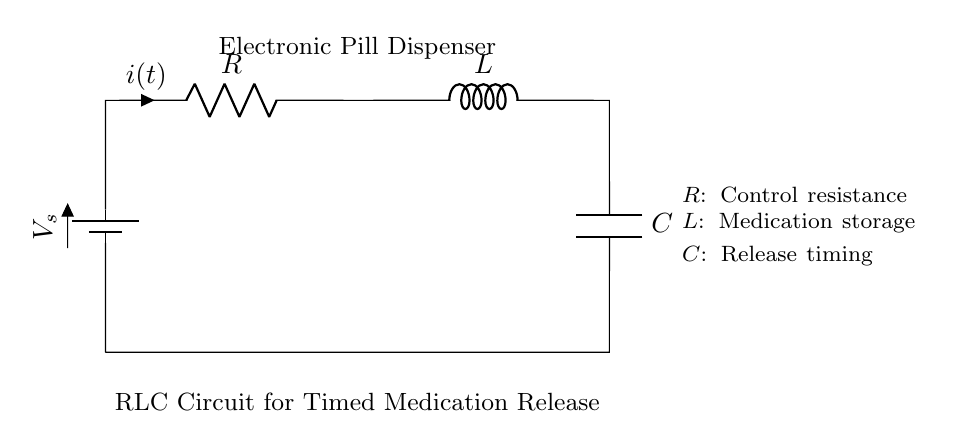What is the control component in the circuit? The control component is the resistor, which is labeled as R. It is used to manage the current flow within the circuit.
Answer: resistor What is the electrical component used for timing in this circuit? The electrical component used for timing is the capacitor, labeled as C. It stores energy and releases it to control the timing of medication release.
Answer: capacitor What do the components R, L, and C represent? R represents control resistance, L represents medication storage, and C represents release timing as described in the circuit diagram.
Answer: control resistance, medication storage, release timing How is the medication stored in the circuit? Medication is stored in the inductor, which is labeled as L. The inductor holds energy in a magnetic field when current passes through it.
Answer: inductor What is the primary purpose of this RLC circuit in an electronic pill dispenser? The primary purpose is to regulate the release of medication over time by controlling current flow, timing, and energy storage.
Answer: regulate medication release What type of circuit is depicted in the diagram? The circuit depicted is a Resistor-Inductor-Capacitor circuit, commonly known as an RLC circuit, which is specifically used for timing applications.
Answer: RLC circuit 